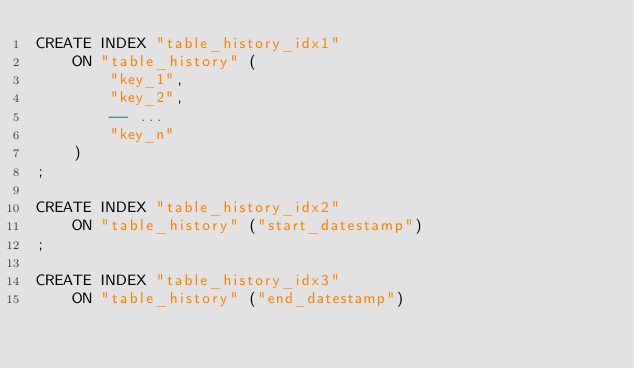Convert code to text. <code><loc_0><loc_0><loc_500><loc_500><_SQL_>CREATE INDEX "table_history_idx1"
	ON "table_history" (
		"key_1",
		"key_2",
		-- ...
		"key_n"
	)
;

CREATE INDEX "table_history_idx2"
	ON "table_history" ("start_datestamp")
;

CREATE INDEX "table_history_idx3"
	ON "table_history" ("end_datestamp")
</code> 